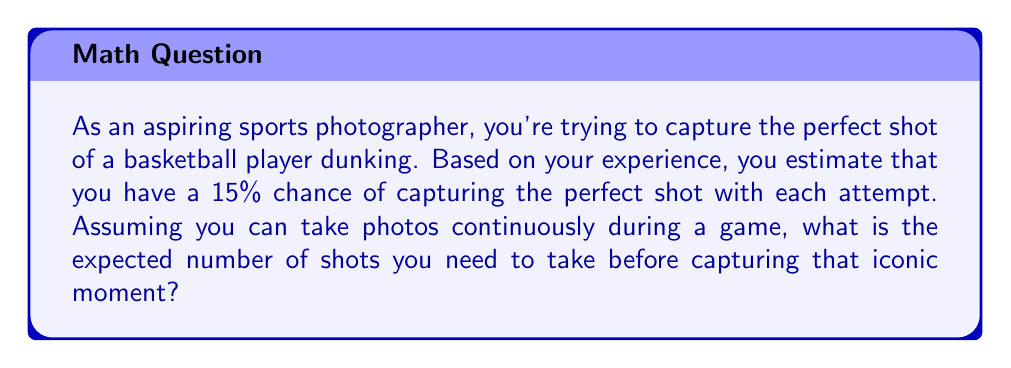Solve this math problem. Let's approach this step-by-step using the concept of expected value:

1) First, we need to recognize that this scenario follows a geometric distribution. The geometric distribution models the number of trials needed to achieve the first success in a series of independent Bernoulli trials.

2) In a geometric distribution, the expected value (E[X]) is given by the formula:

   $$E[X] = \frac{1}{p}$$

   where p is the probability of success on each trial.

3) In this case, p = 0.15 (15% chance of success on each shot)

4) Plugging this into our formula:

   $$E[X] = \frac{1}{0.15}$$

5) Calculating this:

   $$E[X] = 6.67$$

6) Since we can't take a fractional number of photos, we round up to the nearest whole number.

Therefore, you can expect to take 7 shots, on average, before capturing the perfect dunk photo.
Answer: 7 shots 